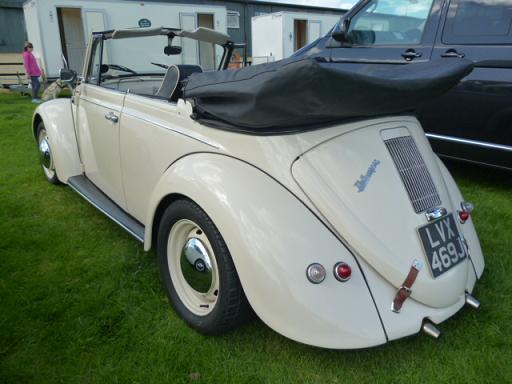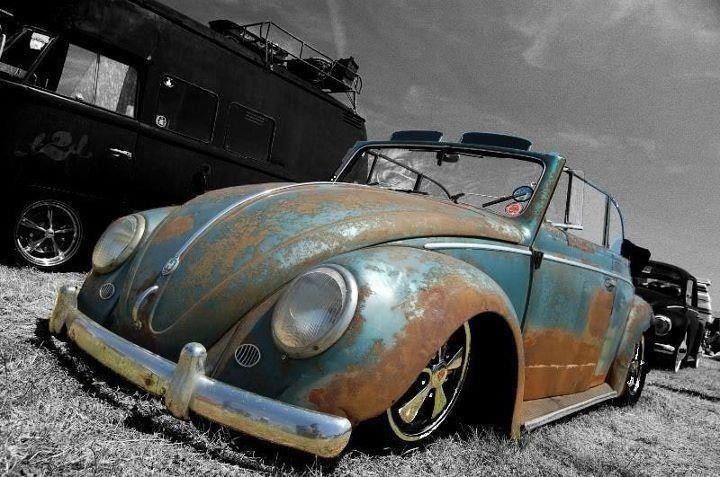The first image is the image on the left, the second image is the image on the right. Analyze the images presented: Is the assertion "An image shows a non-white rear-facing convertible that is not parked on grass." valid? Answer yes or no. No. The first image is the image on the left, the second image is the image on the right. Analyze the images presented: Is the assertion "One of the cars is parked entirely in grass." valid? Answer yes or no. Yes. 